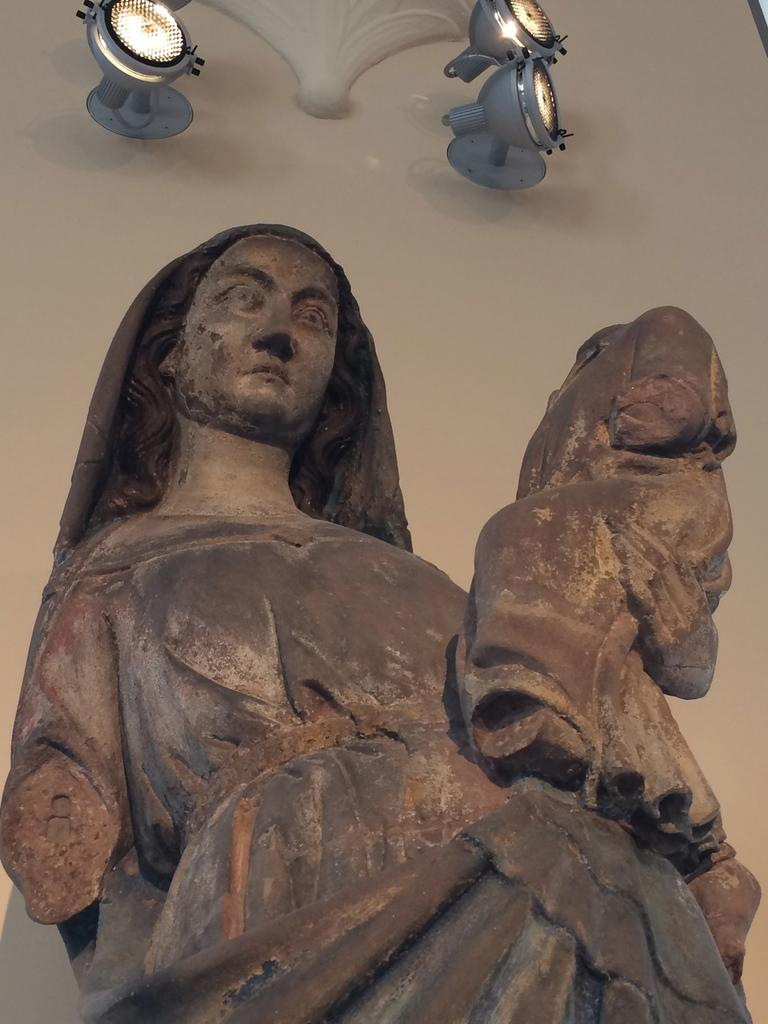What is the main subject of the image? There is a sculpture of a woman in the image. Can you describe the setting of the image? There are lights visible in the background of the image. What type of crime is being committed in the image? There is no crime being committed in the image; it features a sculpture of a woman and lights in the background. Can you tell me how the person in the image is making a request? There is no person making a request in the image; it features a sculpture of a woman and lights in the background. 